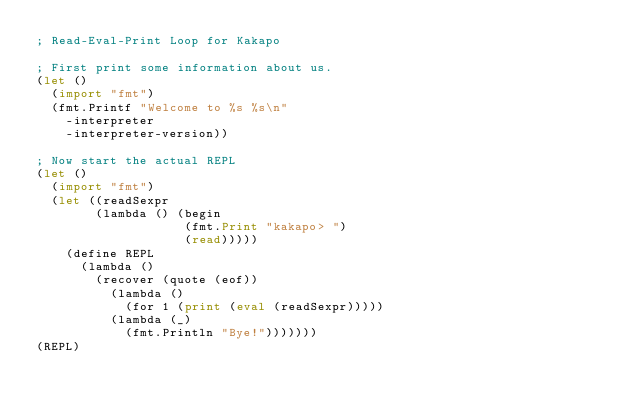<code> <loc_0><loc_0><loc_500><loc_500><_Lisp_>; Read-Eval-Print Loop for Kakapo

; First print some information about us.
(let ()
  (import "fmt")
  (fmt.Printf "Welcome to %s %s\n"
    -interpreter
    -interpreter-version))

; Now start the actual REPL
(let ()
  (import "fmt")
  (let ((readSexpr
        (lambda () (begin
                    (fmt.Print "kakapo> ")
                    (read)))))
    (define REPL
      (lambda ()
        (recover (quote (eof))
          (lambda ()
            (for 1 (print (eval (readSexpr)))))
          (lambda (_)
            (fmt.Println "Bye!")))))))
(REPL)
</code> 